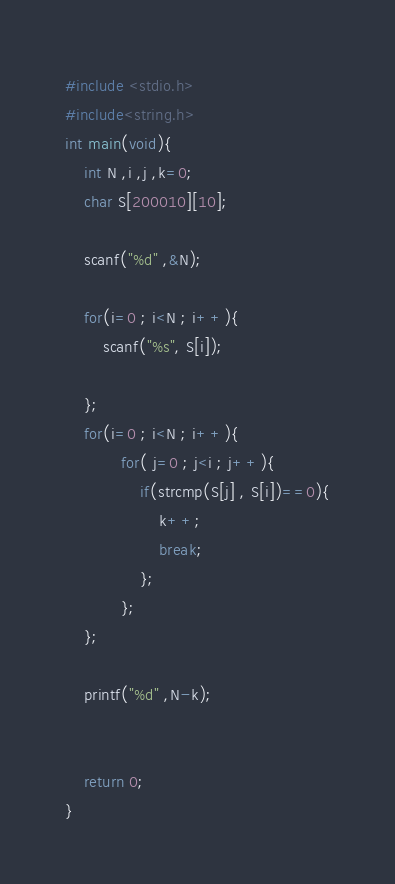Convert code to text. <code><loc_0><loc_0><loc_500><loc_500><_C_>#include <stdio.h>
#include<string.h>
int main(void){
    int N ,i ,j ,k=0;
    char S[200010][10];

    scanf("%d" ,&N);

    for(i=0 ; i<N ; i++){
        scanf("%s", S[i]);
        
    };
    for(i=0 ; i<N ; i++){
            for( j=0 ; j<i ; j++){
                if(strcmp(S[j] , S[i])==0){
                    k++;
                    break;
                };
            };
    };

    printf("%d" ,N-k);


    return 0;
}</code> 